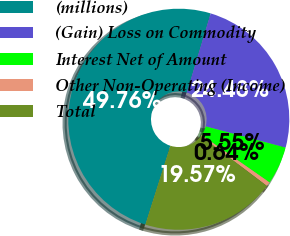<chart> <loc_0><loc_0><loc_500><loc_500><pie_chart><fcel>(millions)<fcel>(Gain) Loss on Commodity<fcel>Interest Net of Amount<fcel>Other Non-Operating (Income)<fcel>Total<nl><fcel>49.76%<fcel>24.48%<fcel>5.55%<fcel>0.64%<fcel>19.57%<nl></chart> 